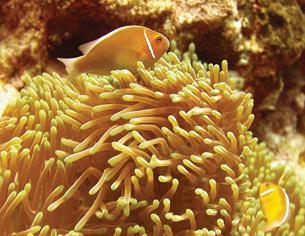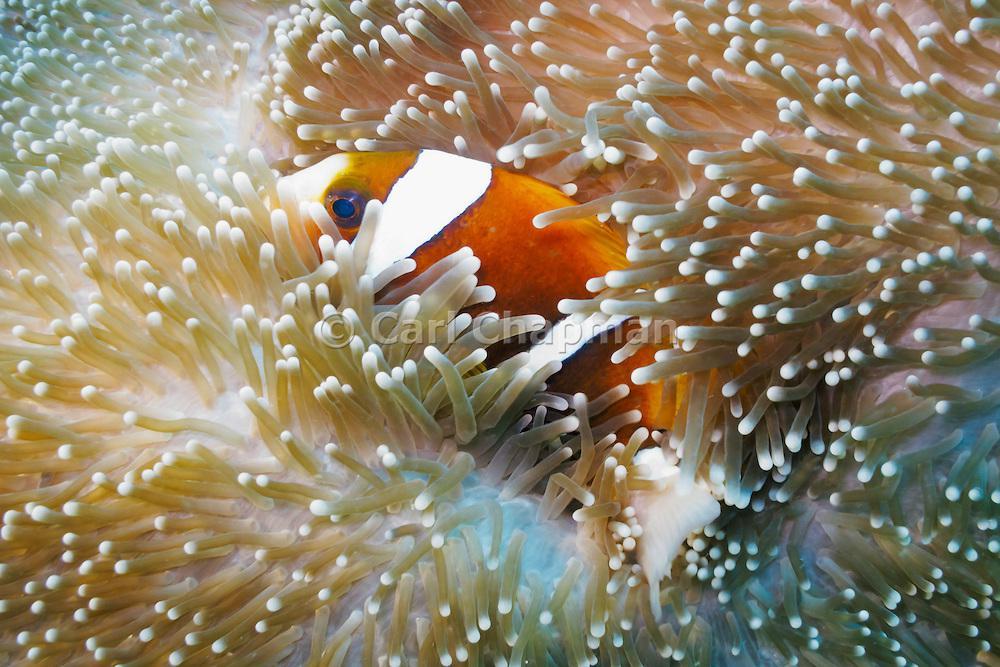The first image is the image on the left, the second image is the image on the right. Considering the images on both sides, is "One image shows exactly one clownfish, which is angled facing rightward above pale anemone tendrils, and the other image includes two clownfish with three stripes each visible in the foreground swimming by pale anemone tendrils." valid? Answer yes or no. No. 